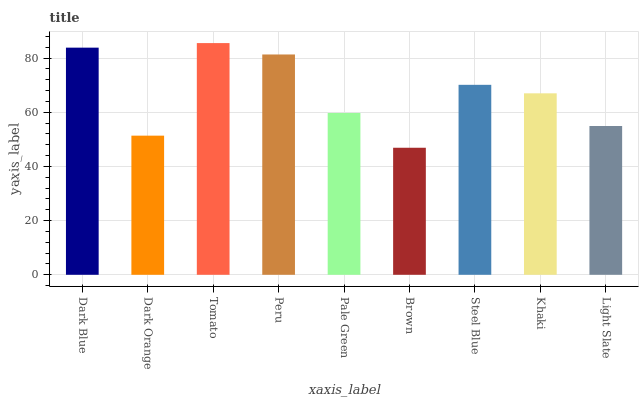Is Brown the minimum?
Answer yes or no. Yes. Is Tomato the maximum?
Answer yes or no. Yes. Is Dark Orange the minimum?
Answer yes or no. No. Is Dark Orange the maximum?
Answer yes or no. No. Is Dark Blue greater than Dark Orange?
Answer yes or no. Yes. Is Dark Orange less than Dark Blue?
Answer yes or no. Yes. Is Dark Orange greater than Dark Blue?
Answer yes or no. No. Is Dark Blue less than Dark Orange?
Answer yes or no. No. Is Khaki the high median?
Answer yes or no. Yes. Is Khaki the low median?
Answer yes or no. Yes. Is Peru the high median?
Answer yes or no. No. Is Light Slate the low median?
Answer yes or no. No. 